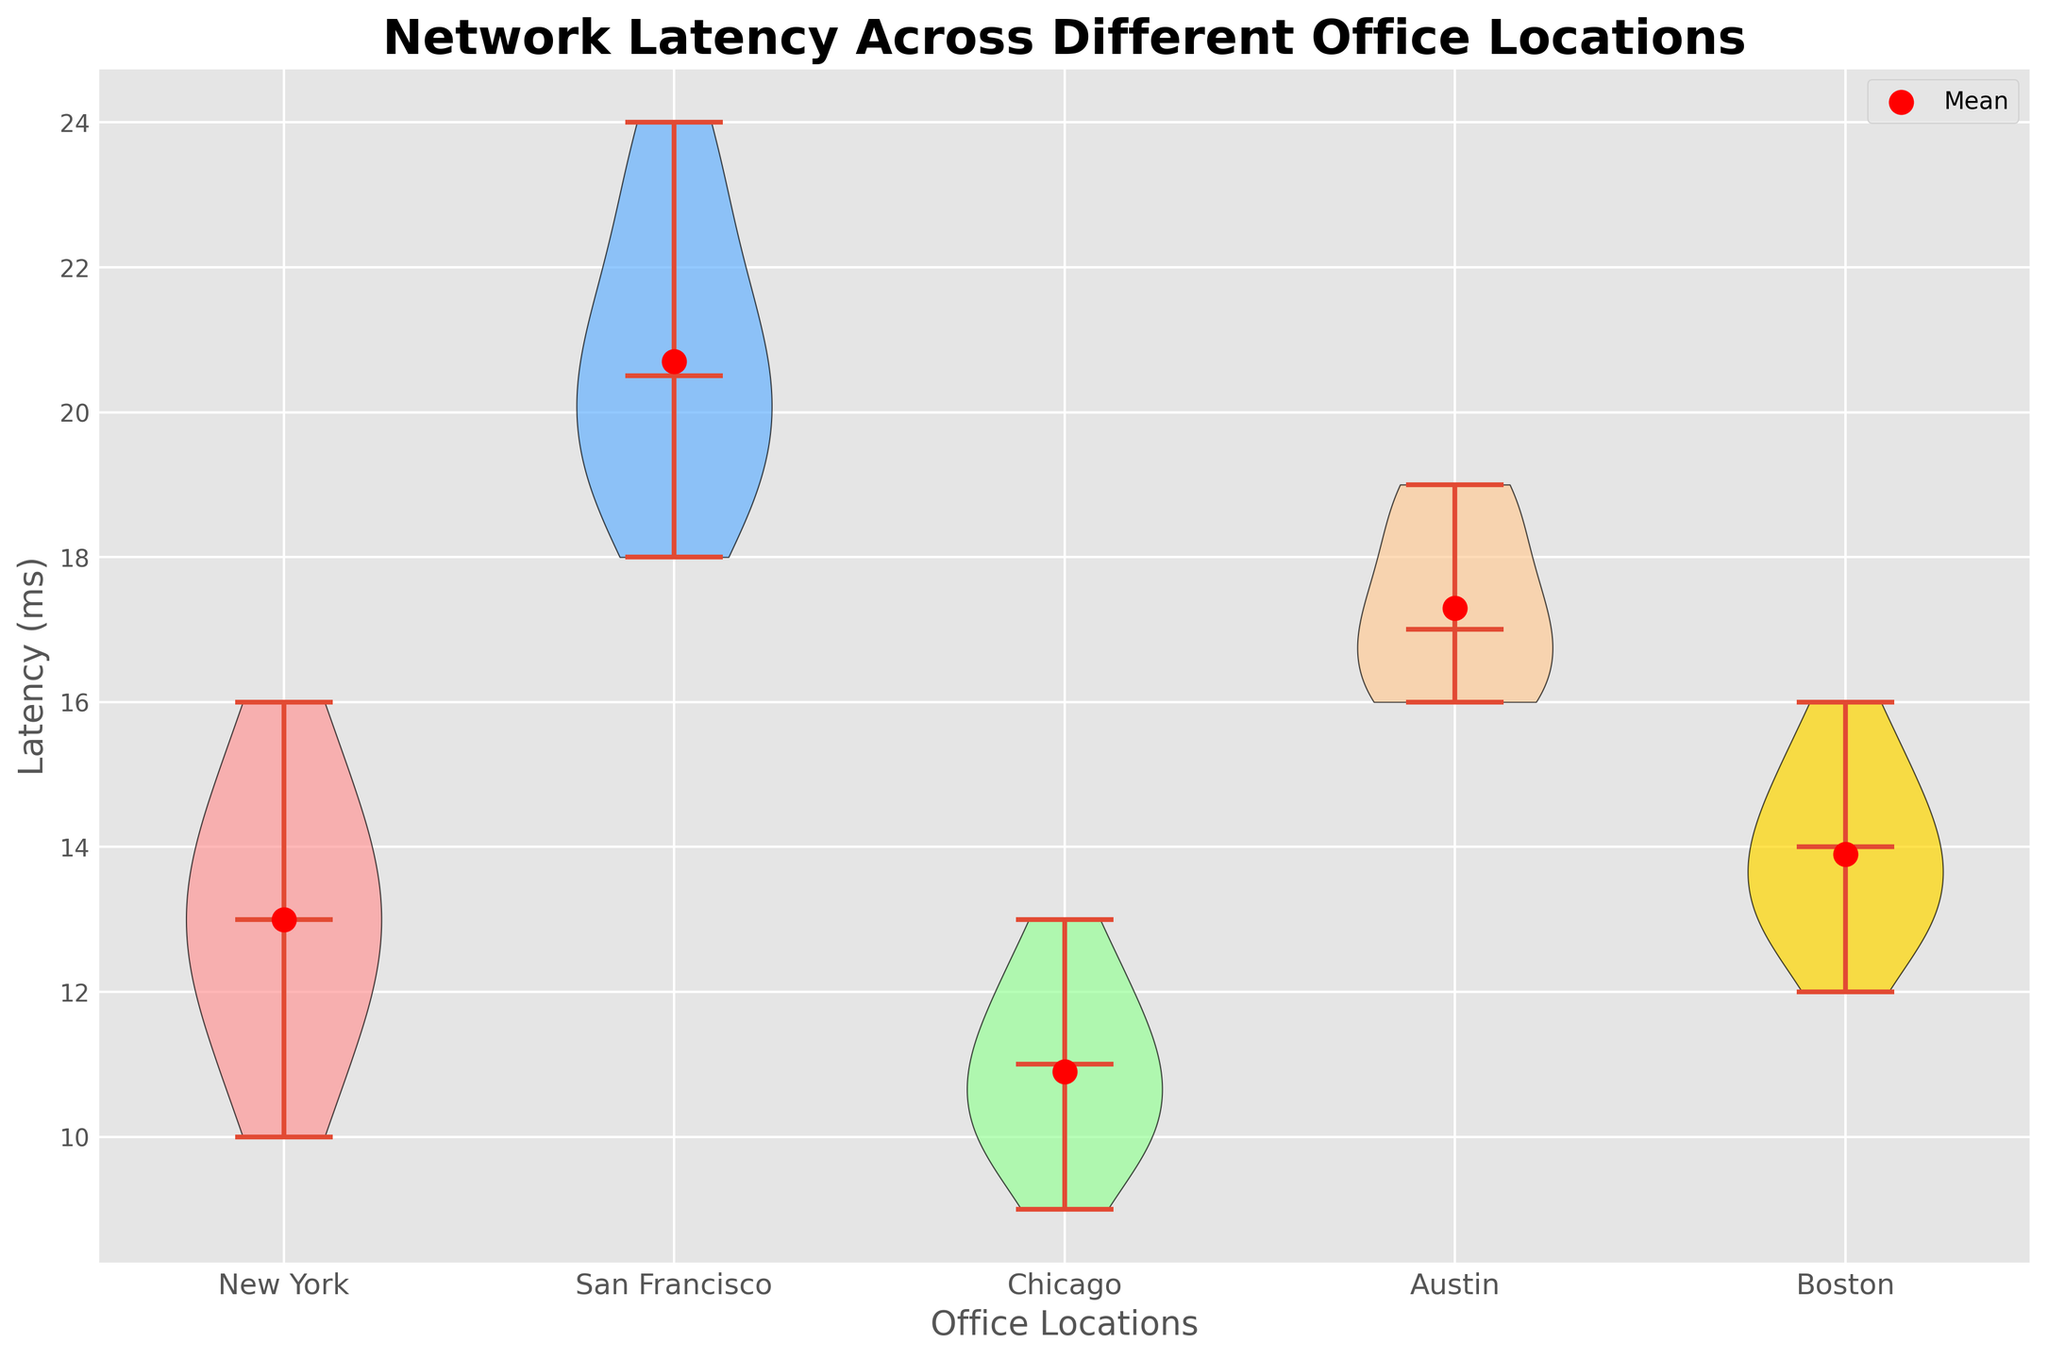What is the median network latency in San Francisco? To find the median network latency for San Francisco, look at the violin plot representing San Francisco. The median is indicated by the thick horizontal line within the plot.
Answer: 20 ms Which location has the highest mean network latency? Look for the red circle markers, which indicate the mean latency for each location. Identify the highest positioned red circle.
Answer: San Francisco How does the median network latency in Boston compare to that in New York? Check the thick horizontal lines within the violin plots for Boston and New York. Compare the positions of these lines to determine which one is higher.
Answer: Boston's median is higher than New York's What is the range of network latency in Austin? The range is determined by the difference between the highest and lowest values within the plot. Look for the uppermost and lowermost points in the Austin violin plot.
Answer: 16 to 19 ms Which location has the smallest spread in network latency? The spread is indicated by the width of the violin plots. Look for the narrowest plot to determine the smallest spread.
Answer: Chicago Is the mean latency in Austin greater than that in Chicago? Compare the positions of the red circle markers in the Austin and Chicago violin plots to see which one is higher.
Answer: Yes, the mean latency in Austin is greater What is the most common range of network latency in New York? Identify where the violin plot for New York is widest, as this indicates the most common range of values.
Answer: 12 to 14 ms Which location shows the widest variation in network latency? Look for the location with the widest and most spread-out violin plot. This indicates the greatest variation.
Answer: San Francisco 